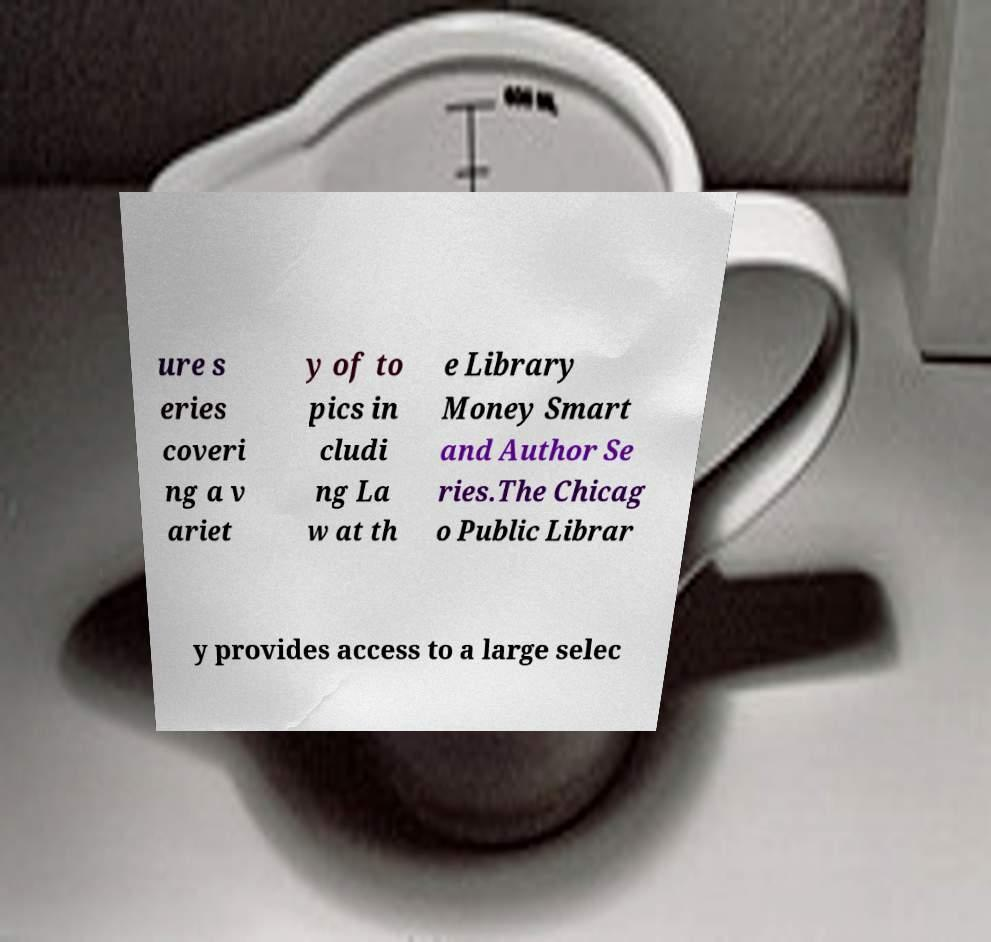Please identify and transcribe the text found in this image. ure s eries coveri ng a v ariet y of to pics in cludi ng La w at th e Library Money Smart and Author Se ries.The Chicag o Public Librar y provides access to a large selec 